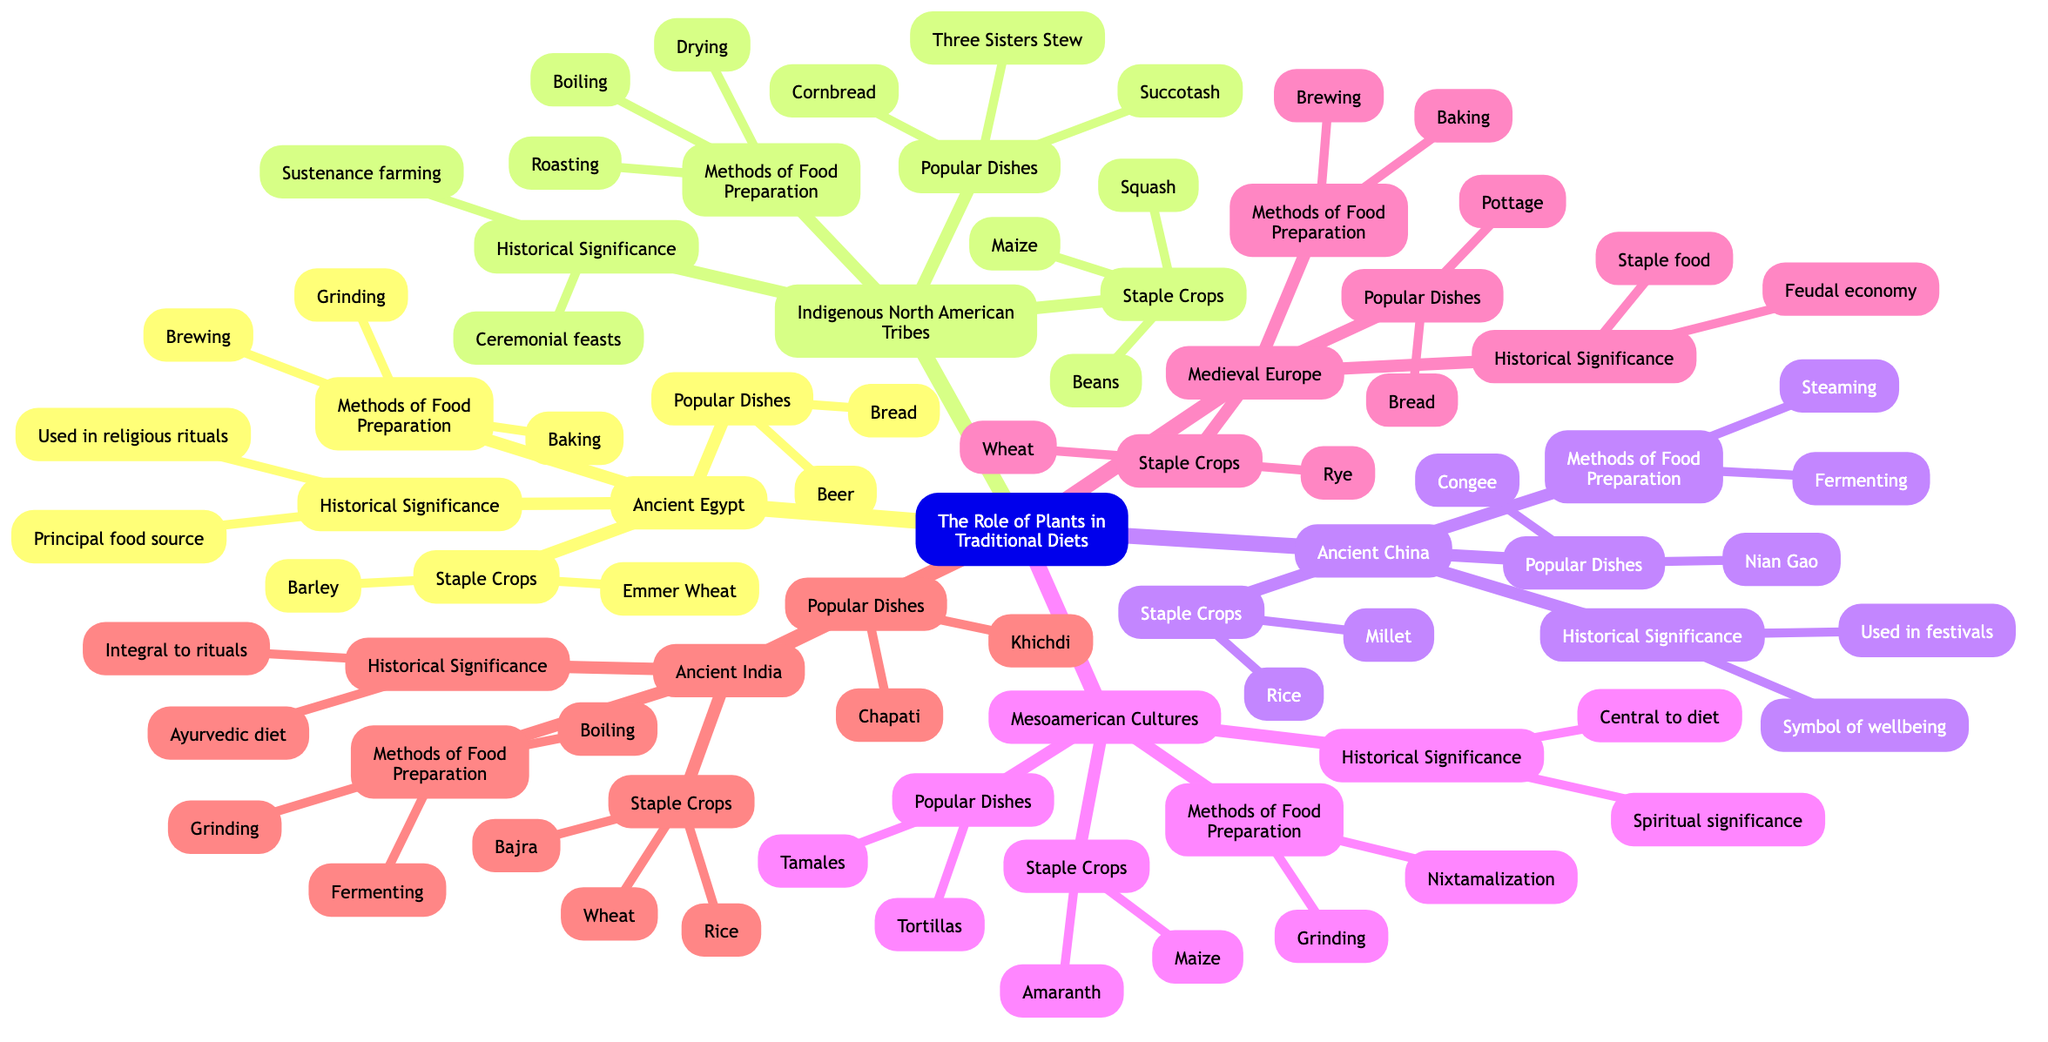What staple crops are associated with Ancient Egypt? The node labeled "Staple Crops" under "Ancient Egypt" lists "Emmer Wheat" and "Barley." These are the primary crops highlighted for this culture.
Answer: Emmer Wheat, Barley How many popular dishes are listed for Indigenous North American Tribes? The node for "Popular Dishes" under "Indigenous North American Tribes" displays three dishes: "Cornbread," "Succotash," and "Three Sisters Stew." Counting them gives a total of three.
Answer: 3 What is a common method of food preparation in Ancient China? The node "Methods of Food Preparation" under "Ancient China" lists "Steaming" and "Fermenting." Both methods are described, with "Steaming" being a notably traditional technique.
Answer: Steaming What cultural significance can be traced from the staple crops of Mesoamerican cultures? The node "Historical Significance" for "Mesoamerican Cultures" states that these crops were "Central to diet" and had "Spiritual significance." This illustrates the importance of both daily sustenance and ritual practices.
Answer: Central to diet, Spiritual significance Which crop from Ancient India is used in the dish Khichdi? In the "Popular Dishes" section for Ancient India, "Khichdi" is mentioned, and the "Staple Crops" node includes "Rice" which is a primary ingredient in this dish.
Answer: Rice What methods of food preparation are described under Medieval Europe? The "Methods of Food Preparation" node for "Medieval Europe" includes "Baking" and "Brewing," which were crucial for making bread and beer, respectively, during this period.
Answer: Baking, Brewing What shared staple crop is common between Indigenous North American Tribes and Mesoamerican Cultures? Both "Indigenous North American Tribes" and "Mesoamerican Cultures" have "Maize" listed in their "Staple Crops" nodes, indicating its wide usage across these cultures.
Answer: Maize How does the role of plants in ancient diets compare to contemporary diets? While contemporary diets may vary significantly, historical data suggests that plants were central like "Rice" in Ancient China for well-being, indicating a lasting significance. However, the dominance of specific crops has changed with globalization and dietary shifts.
Answer: Central to diet 